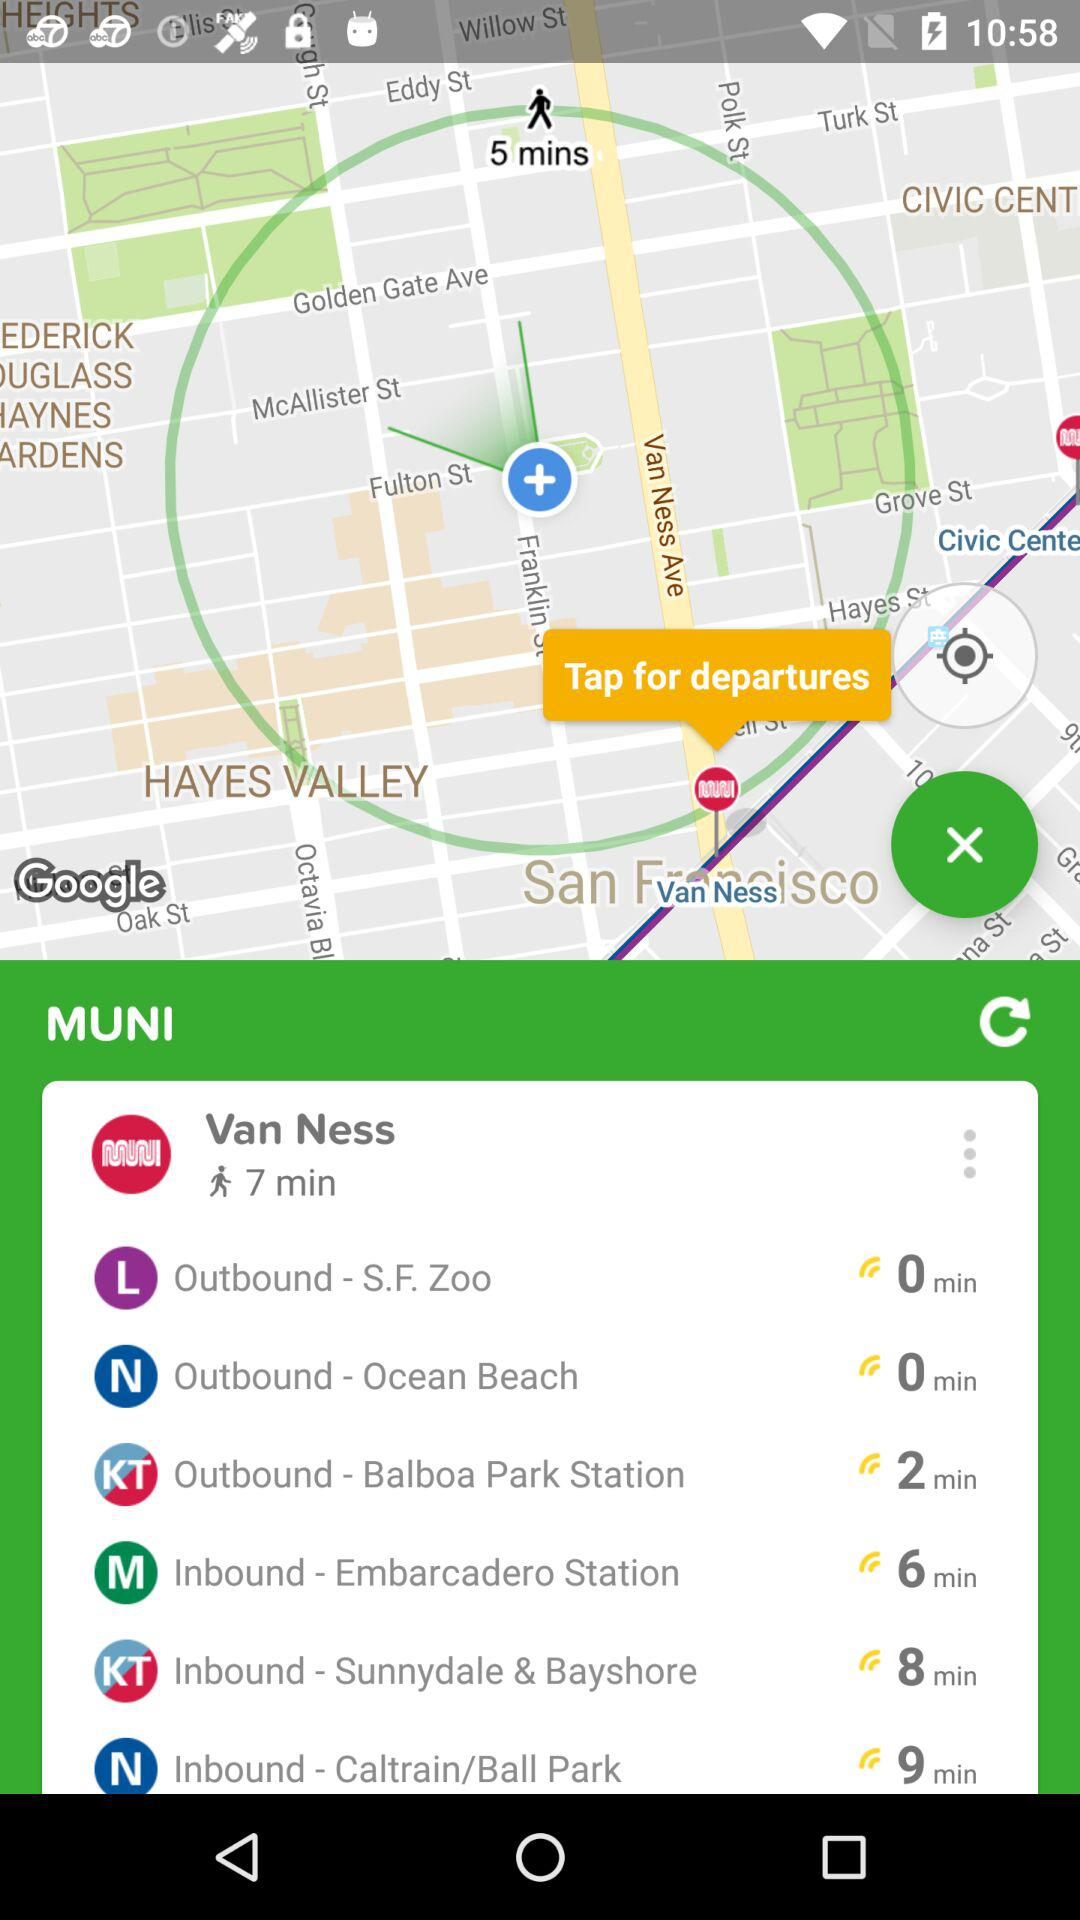How many minutes will it take to go to Van Ness by walking? It will take 7 minutes to walk to Van Ness. 